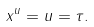<formula> <loc_0><loc_0><loc_500><loc_500>x ^ { u } = u = \tau .</formula> 